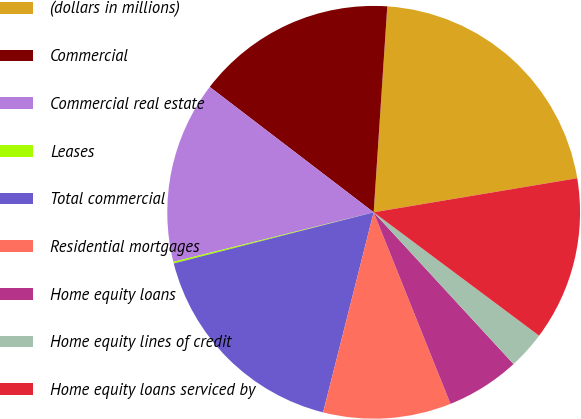<chart> <loc_0><loc_0><loc_500><loc_500><pie_chart><fcel>(dollars in millions)<fcel>Commercial<fcel>Commercial real estate<fcel>Leases<fcel>Total commercial<fcel>Residential mortgages<fcel>Home equity loans<fcel>Home equity lines of credit<fcel>Home equity loans serviced by<nl><fcel>21.31%<fcel>15.66%<fcel>14.25%<fcel>0.13%<fcel>17.07%<fcel>10.01%<fcel>5.78%<fcel>2.95%<fcel>12.84%<nl></chart> 